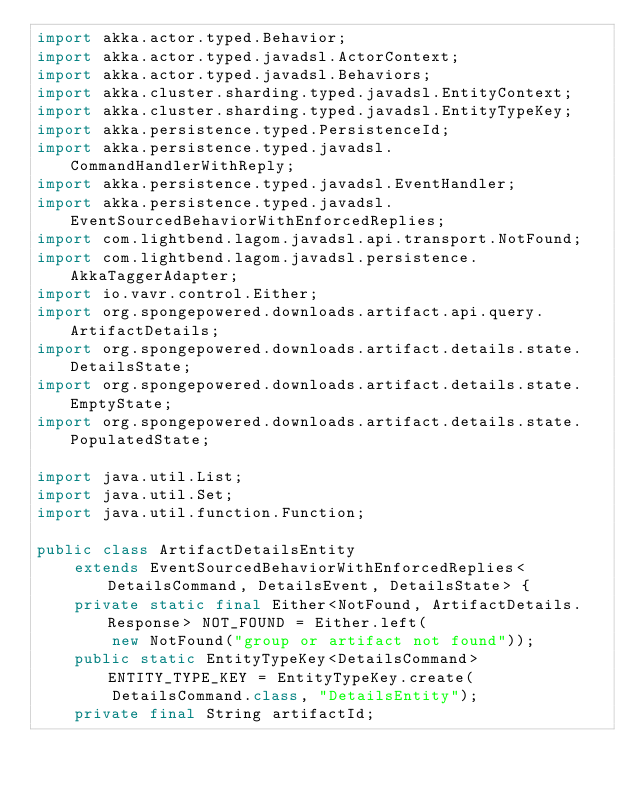<code> <loc_0><loc_0><loc_500><loc_500><_Java_>import akka.actor.typed.Behavior;
import akka.actor.typed.javadsl.ActorContext;
import akka.actor.typed.javadsl.Behaviors;
import akka.cluster.sharding.typed.javadsl.EntityContext;
import akka.cluster.sharding.typed.javadsl.EntityTypeKey;
import akka.persistence.typed.PersistenceId;
import akka.persistence.typed.javadsl.CommandHandlerWithReply;
import akka.persistence.typed.javadsl.EventHandler;
import akka.persistence.typed.javadsl.EventSourcedBehaviorWithEnforcedReplies;
import com.lightbend.lagom.javadsl.api.transport.NotFound;
import com.lightbend.lagom.javadsl.persistence.AkkaTaggerAdapter;
import io.vavr.control.Either;
import org.spongepowered.downloads.artifact.api.query.ArtifactDetails;
import org.spongepowered.downloads.artifact.details.state.DetailsState;
import org.spongepowered.downloads.artifact.details.state.EmptyState;
import org.spongepowered.downloads.artifact.details.state.PopulatedState;

import java.util.List;
import java.util.Set;
import java.util.function.Function;

public class ArtifactDetailsEntity
    extends EventSourcedBehaviorWithEnforcedReplies<DetailsCommand, DetailsEvent, DetailsState> {
    private static final Either<NotFound, ArtifactDetails.Response> NOT_FOUND = Either.left(
        new NotFound("group or artifact not found"));
    public static EntityTypeKey<DetailsCommand> ENTITY_TYPE_KEY = EntityTypeKey.create(
        DetailsCommand.class, "DetailsEntity");
    private final String artifactId;</code> 